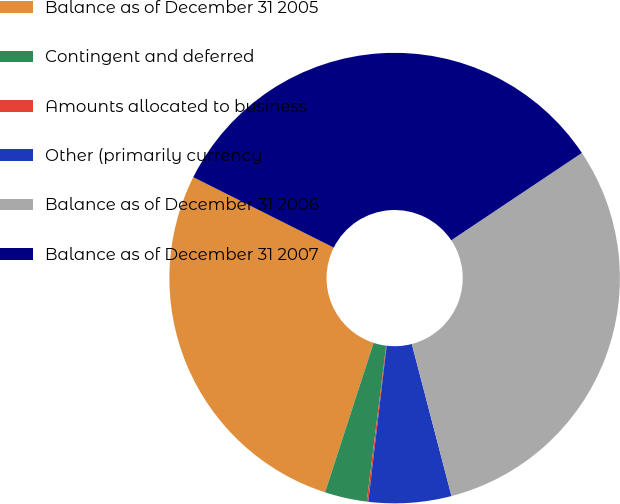Convert chart. <chart><loc_0><loc_0><loc_500><loc_500><pie_chart><fcel>Balance as of December 31 2005<fcel>Contingent and deferred<fcel>Amounts allocated to business<fcel>Other (primarily currency<fcel>Balance as of December 31 2006<fcel>Balance as of December 31 2007<nl><fcel>27.4%<fcel>3.02%<fcel>0.11%<fcel>5.93%<fcel>30.32%<fcel>33.23%<nl></chart> 